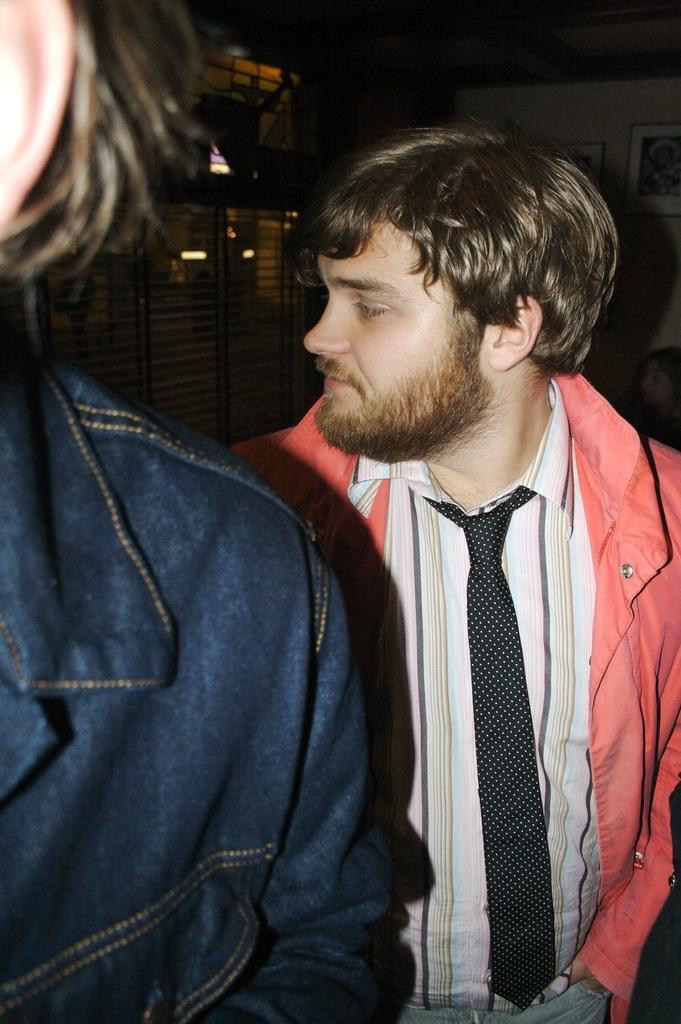In one or two sentences, can you explain what this image depicts? In this image I can see two persons and in the background I can see fence and the wall , on the wall I can see photo frame, in front of the wall I can see person. 